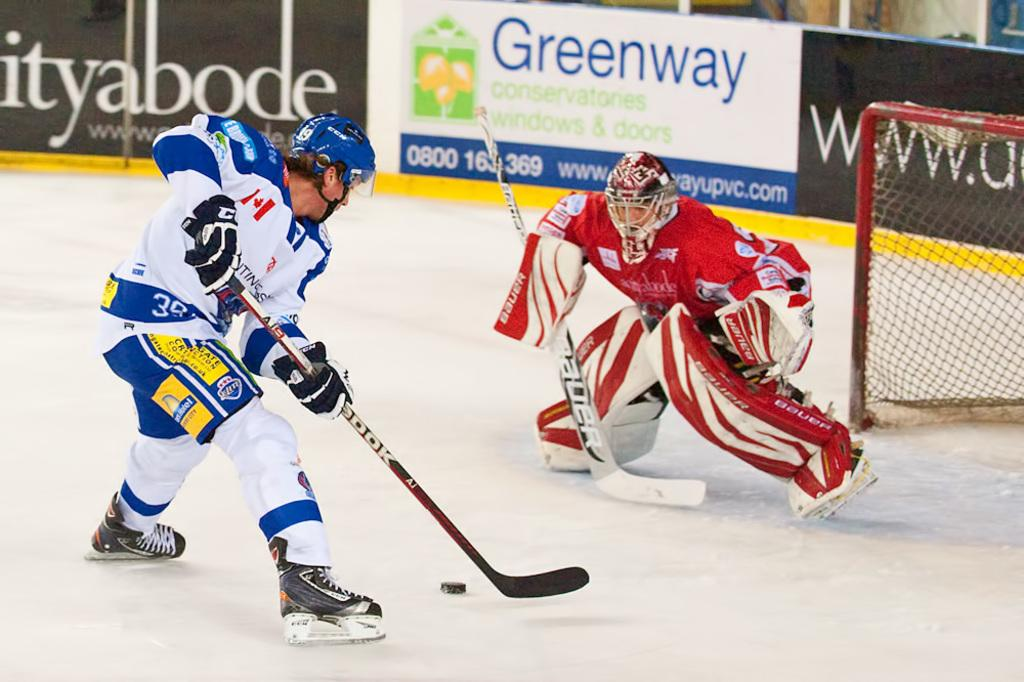Provide a one-sentence caption for the provided image. A Greenway conservatories ad sponsors a hockey game. 